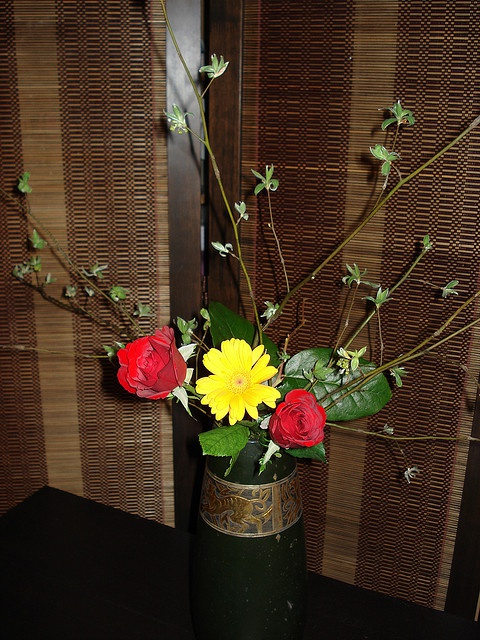Describe the objects in this image and their specific colors. I can see potted plant in black, maroon, olive, and gray tones and vase in black, olive, maroon, and gray tones in this image. 